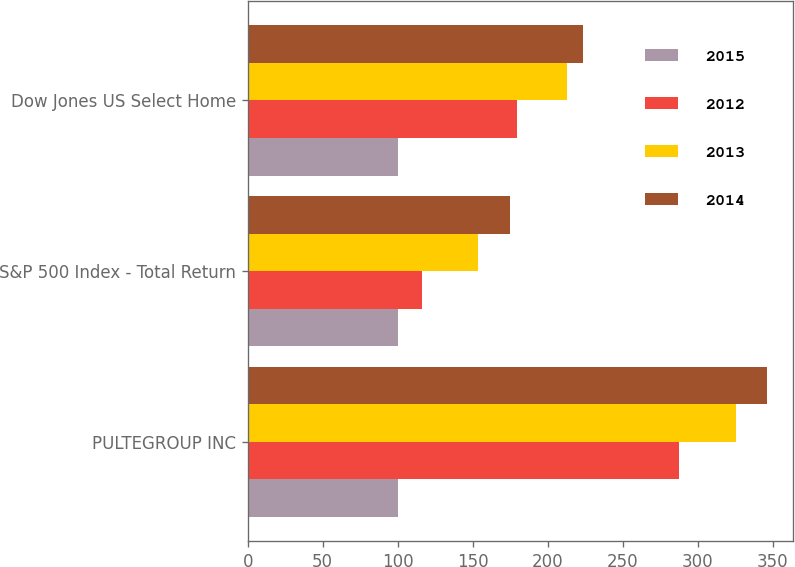<chart> <loc_0><loc_0><loc_500><loc_500><stacked_bar_chart><ecel><fcel>PULTEGROUP INC<fcel>S&P 500 Index - Total Return<fcel>Dow Jones US Select Home<nl><fcel>2015<fcel>100<fcel>100<fcel>100<nl><fcel>2012<fcel>287.8<fcel>116<fcel>179.68<nl><fcel>2013<fcel>325.2<fcel>153.57<fcel>212.75<nl><fcel>2014<fcel>346.27<fcel>174.6<fcel>223.71<nl></chart> 